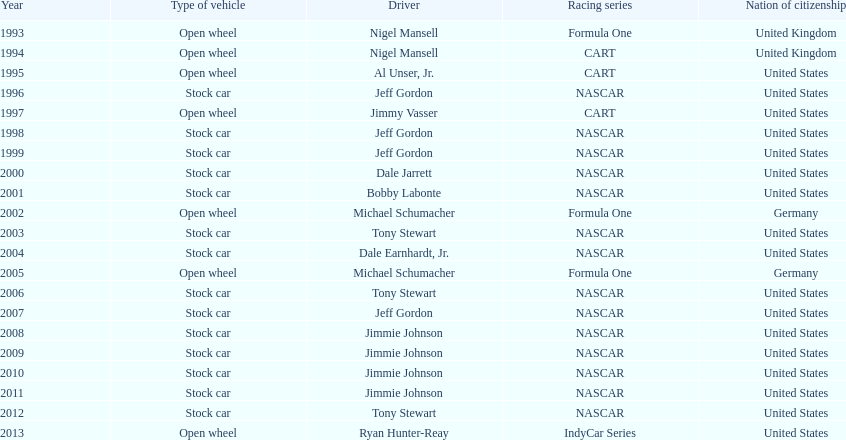Which racing series has the highest total of winners? NASCAR. 